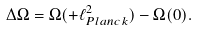Convert formula to latex. <formula><loc_0><loc_0><loc_500><loc_500>\Delta \Omega = \Omega ( + \ell _ { P l a n c k } ^ { 2 } ) - \Omega ( 0 ) .</formula> 